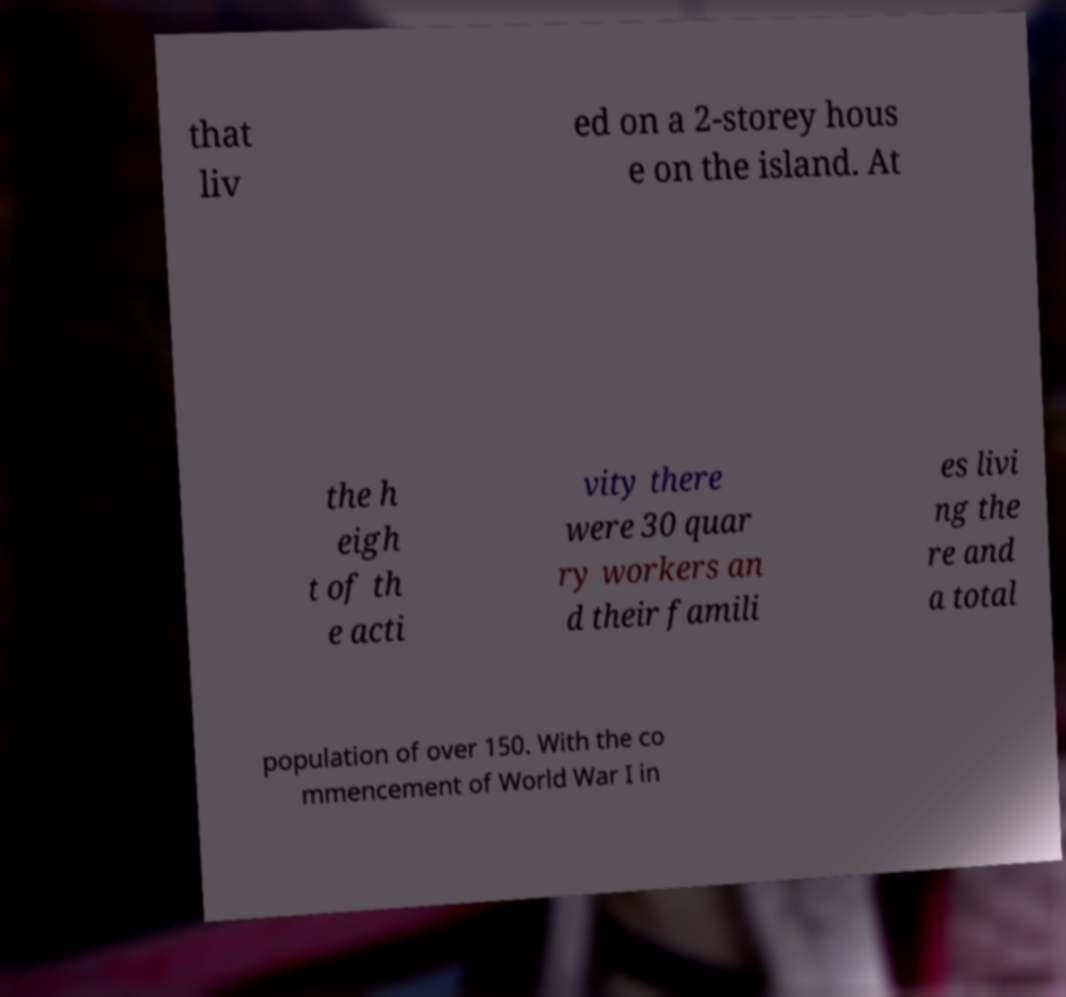What messages or text are displayed in this image? I need them in a readable, typed format. that liv ed on a 2-storey hous e on the island. At the h eigh t of th e acti vity there were 30 quar ry workers an d their famili es livi ng the re and a total population of over 150. With the co mmencement of World War I in 